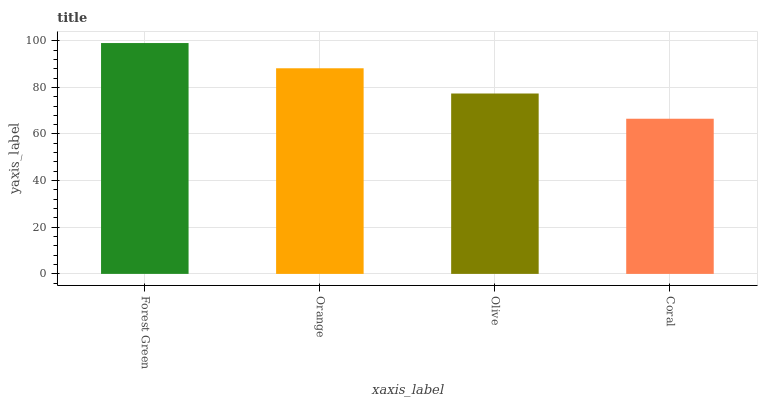Is Coral the minimum?
Answer yes or no. Yes. Is Forest Green the maximum?
Answer yes or no. Yes. Is Orange the minimum?
Answer yes or no. No. Is Orange the maximum?
Answer yes or no. No. Is Forest Green greater than Orange?
Answer yes or no. Yes. Is Orange less than Forest Green?
Answer yes or no. Yes. Is Orange greater than Forest Green?
Answer yes or no. No. Is Forest Green less than Orange?
Answer yes or no. No. Is Orange the high median?
Answer yes or no. Yes. Is Olive the low median?
Answer yes or no. Yes. Is Olive the high median?
Answer yes or no. No. Is Coral the low median?
Answer yes or no. No. 